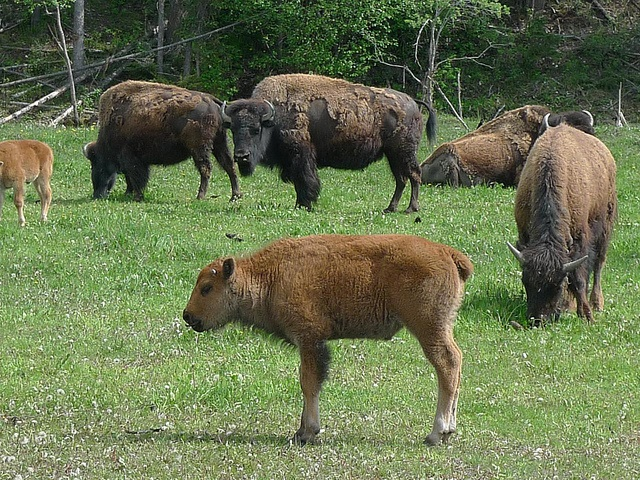Describe the objects in this image and their specific colors. I can see cow in black and gray tones, cow in black and gray tones, cow in black, gray, and tan tones, cow in black and gray tones, and cow in black and gray tones in this image. 